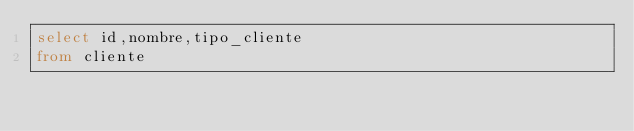Convert code to text. <code><loc_0><loc_0><loc_500><loc_500><_SQL_>select id,nombre,tipo_cliente
from cliente</code> 